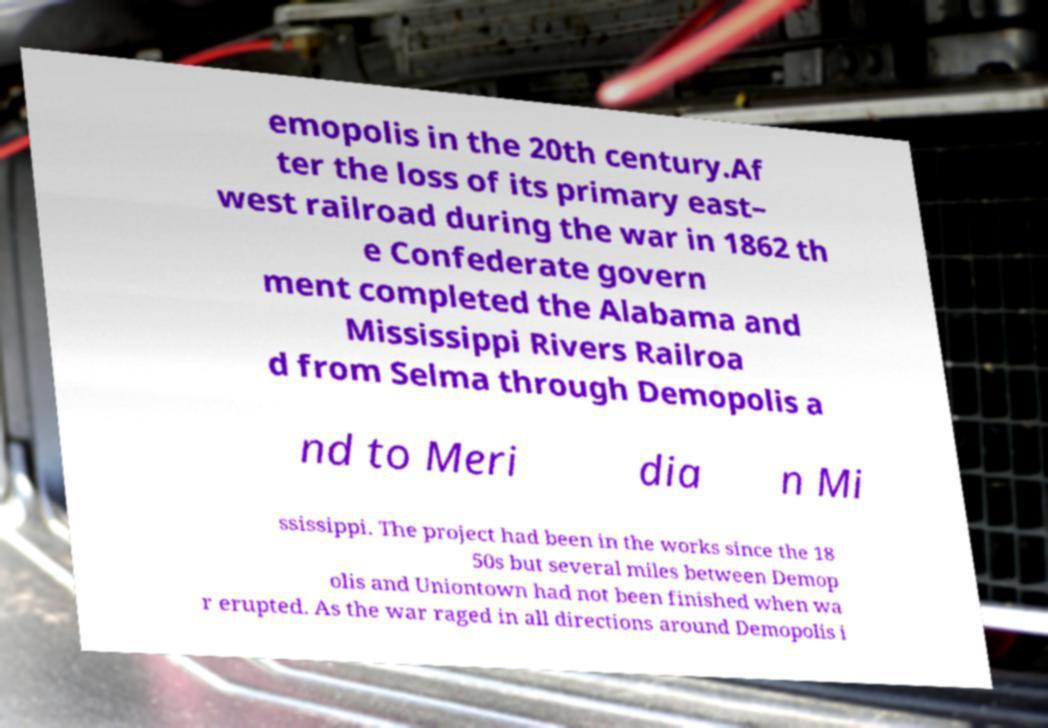Please read and relay the text visible in this image. What does it say? emopolis in the 20th century.Af ter the loss of its primary east– west railroad during the war in 1862 th e Confederate govern ment completed the Alabama and Mississippi Rivers Railroa d from Selma through Demopolis a nd to Meri dia n Mi ssissippi. The project had been in the works since the 18 50s but several miles between Demop olis and Uniontown had not been finished when wa r erupted. As the war raged in all directions around Demopolis i 